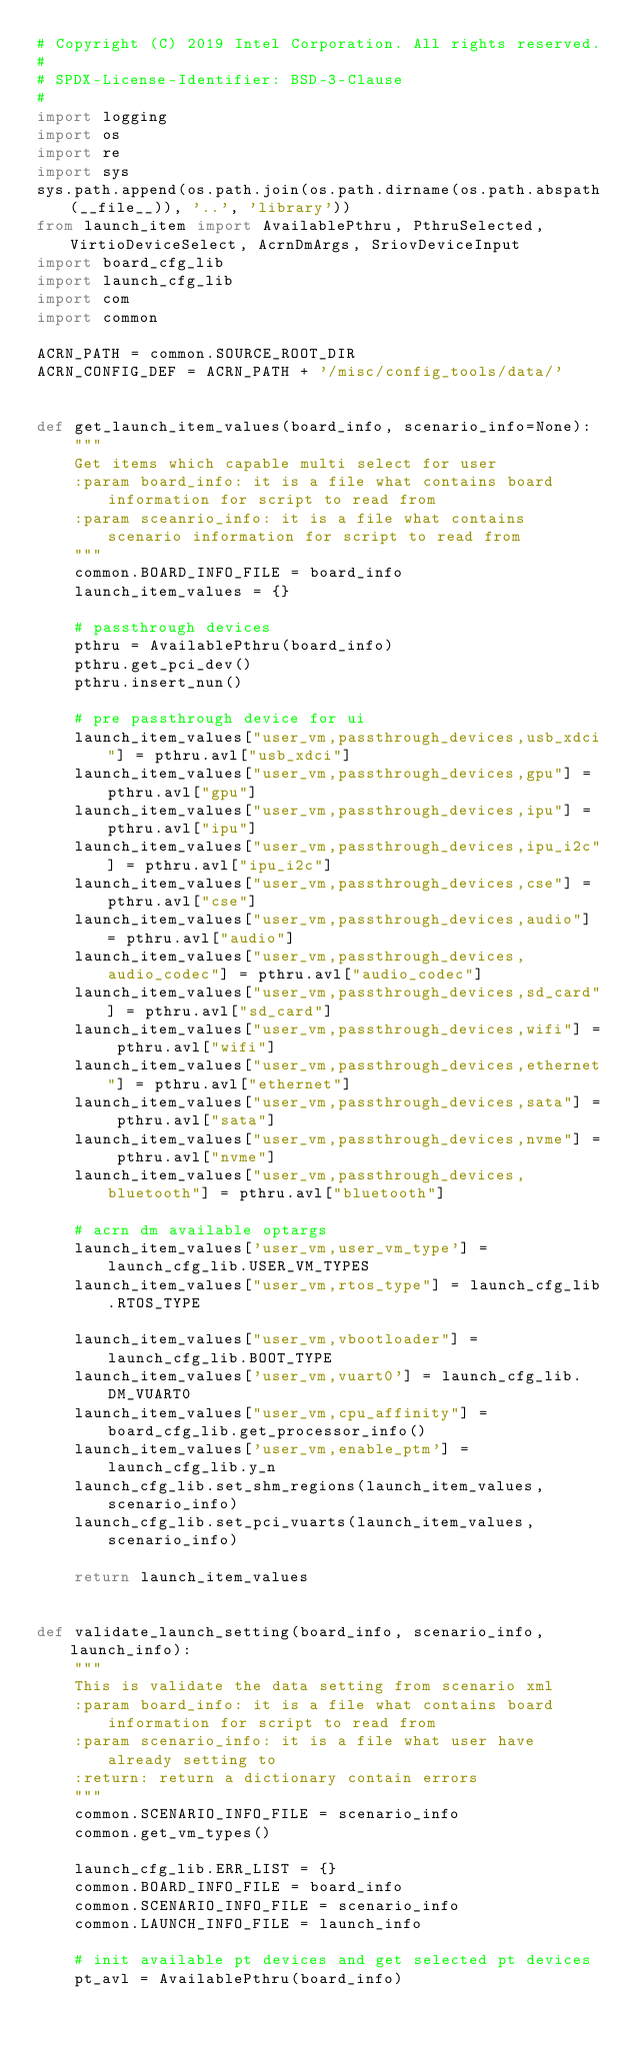Convert code to text. <code><loc_0><loc_0><loc_500><loc_500><_Python_># Copyright (C) 2019 Intel Corporation. All rights reserved.
#
# SPDX-License-Identifier: BSD-3-Clause
#
import logging
import os
import re
import sys
sys.path.append(os.path.join(os.path.dirname(os.path.abspath(__file__)), '..', 'library'))
from launch_item import AvailablePthru, PthruSelected, VirtioDeviceSelect, AcrnDmArgs, SriovDeviceInput
import board_cfg_lib
import launch_cfg_lib
import com
import common

ACRN_PATH = common.SOURCE_ROOT_DIR
ACRN_CONFIG_DEF = ACRN_PATH + '/misc/config_tools/data/'


def get_launch_item_values(board_info, scenario_info=None):
    """
    Get items which capable multi select for user
    :param board_info: it is a file what contains board information for script to read from
    :param sceanrio_info: it is a file what contains scenario information for script to read from
    """
    common.BOARD_INFO_FILE = board_info
    launch_item_values = {}

    # passthrough devices
    pthru = AvailablePthru(board_info)
    pthru.get_pci_dev()
    pthru.insert_nun()

    # pre passthrough device for ui
    launch_item_values["user_vm,passthrough_devices,usb_xdci"] = pthru.avl["usb_xdci"]
    launch_item_values["user_vm,passthrough_devices,gpu"] = pthru.avl["gpu"]
    launch_item_values["user_vm,passthrough_devices,ipu"] = pthru.avl["ipu"]
    launch_item_values["user_vm,passthrough_devices,ipu_i2c"] = pthru.avl["ipu_i2c"]
    launch_item_values["user_vm,passthrough_devices,cse"] = pthru.avl["cse"]
    launch_item_values["user_vm,passthrough_devices,audio"] = pthru.avl["audio"]
    launch_item_values["user_vm,passthrough_devices,audio_codec"] = pthru.avl["audio_codec"]
    launch_item_values["user_vm,passthrough_devices,sd_card"] = pthru.avl["sd_card"]
    launch_item_values["user_vm,passthrough_devices,wifi"] = pthru.avl["wifi"]
    launch_item_values["user_vm,passthrough_devices,ethernet"] = pthru.avl["ethernet"]
    launch_item_values["user_vm,passthrough_devices,sata"] = pthru.avl["sata"]
    launch_item_values["user_vm,passthrough_devices,nvme"] = pthru.avl["nvme"]
    launch_item_values["user_vm,passthrough_devices,bluetooth"] = pthru.avl["bluetooth"]

    # acrn dm available optargs
    launch_item_values['user_vm,user_vm_type'] = launch_cfg_lib.USER_VM_TYPES
    launch_item_values["user_vm,rtos_type"] = launch_cfg_lib.RTOS_TYPE

    launch_item_values["user_vm,vbootloader"] = launch_cfg_lib.BOOT_TYPE
    launch_item_values['user_vm,vuart0'] = launch_cfg_lib.DM_VUART0
    launch_item_values["user_vm,cpu_affinity"] = board_cfg_lib.get_processor_info()
    launch_item_values['user_vm,enable_ptm'] = launch_cfg_lib.y_n
    launch_cfg_lib.set_shm_regions(launch_item_values, scenario_info)
    launch_cfg_lib.set_pci_vuarts(launch_item_values, scenario_info)

    return launch_item_values


def validate_launch_setting(board_info, scenario_info, launch_info):
    """
    This is validate the data setting from scenario xml
    :param board_info: it is a file what contains board information for script to read from
    :param scenario_info: it is a file what user have already setting to
    :return: return a dictionary contain errors
    """
    common.SCENARIO_INFO_FILE = scenario_info
    common.get_vm_types()

    launch_cfg_lib.ERR_LIST = {}
    common.BOARD_INFO_FILE = board_info
    common.SCENARIO_INFO_FILE = scenario_info
    common.LAUNCH_INFO_FILE = launch_info

    # init available pt devices and get selected pt devices
    pt_avl = AvailablePthru(board_info)</code> 